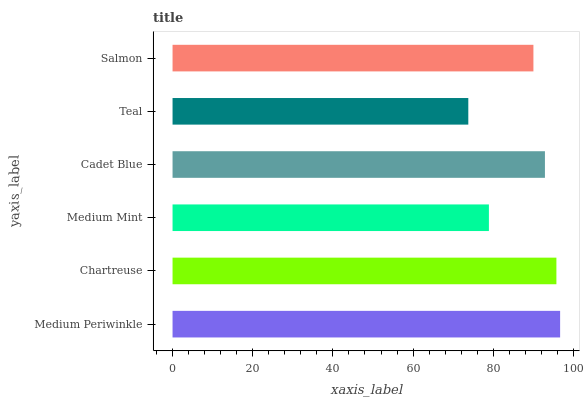Is Teal the minimum?
Answer yes or no. Yes. Is Medium Periwinkle the maximum?
Answer yes or no. Yes. Is Chartreuse the minimum?
Answer yes or no. No. Is Chartreuse the maximum?
Answer yes or no. No. Is Medium Periwinkle greater than Chartreuse?
Answer yes or no. Yes. Is Chartreuse less than Medium Periwinkle?
Answer yes or no. Yes. Is Chartreuse greater than Medium Periwinkle?
Answer yes or no. No. Is Medium Periwinkle less than Chartreuse?
Answer yes or no. No. Is Cadet Blue the high median?
Answer yes or no. Yes. Is Salmon the low median?
Answer yes or no. Yes. Is Teal the high median?
Answer yes or no. No. Is Teal the low median?
Answer yes or no. No. 